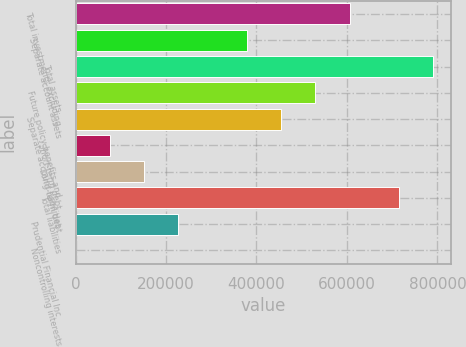<chart> <loc_0><loc_0><loc_500><loc_500><bar_chart><fcel>Total investments excluding<fcel>Separate account assets<fcel>Total assets<fcel>Future policy benefits and<fcel>Separate account liabilities<fcel>Short-term debt<fcel>Long-term debt<fcel>Total liabilities<fcel>Prudential Financial Inc<fcel>Noncontrolling interests<nl><fcel>605917<fcel>378710<fcel>791200<fcel>530182<fcel>454446<fcel>75768.5<fcel>151504<fcel>715465<fcel>227240<fcel>33<nl></chart> 